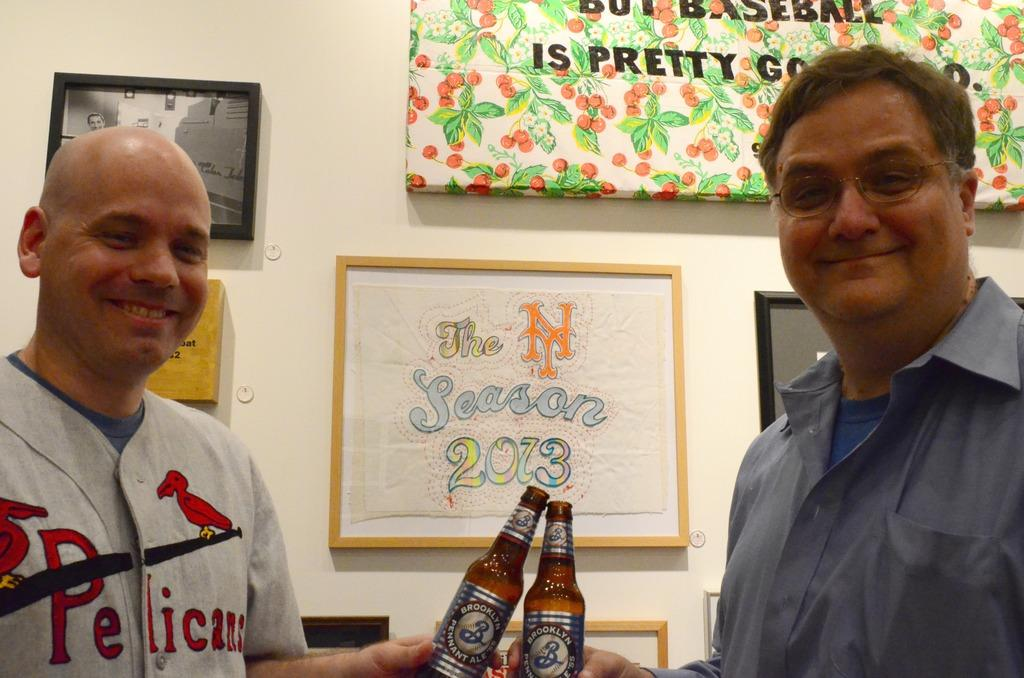How many people are in the image? There are two persons in the image. What are the persons holding in their hands? The persons are holding bottles. What is the facial expression of the persons in the image? The persons are smiling. What can be seen on the wall in the image? There are posters and photos on the wall. Is there a fight happening between the two persons in the image? No, there is no fight happening between the two persons in the image; they are both smiling and holding bottles. Can you see a tongue sticking out in the image? No, there is no tongue sticking out in the image. 